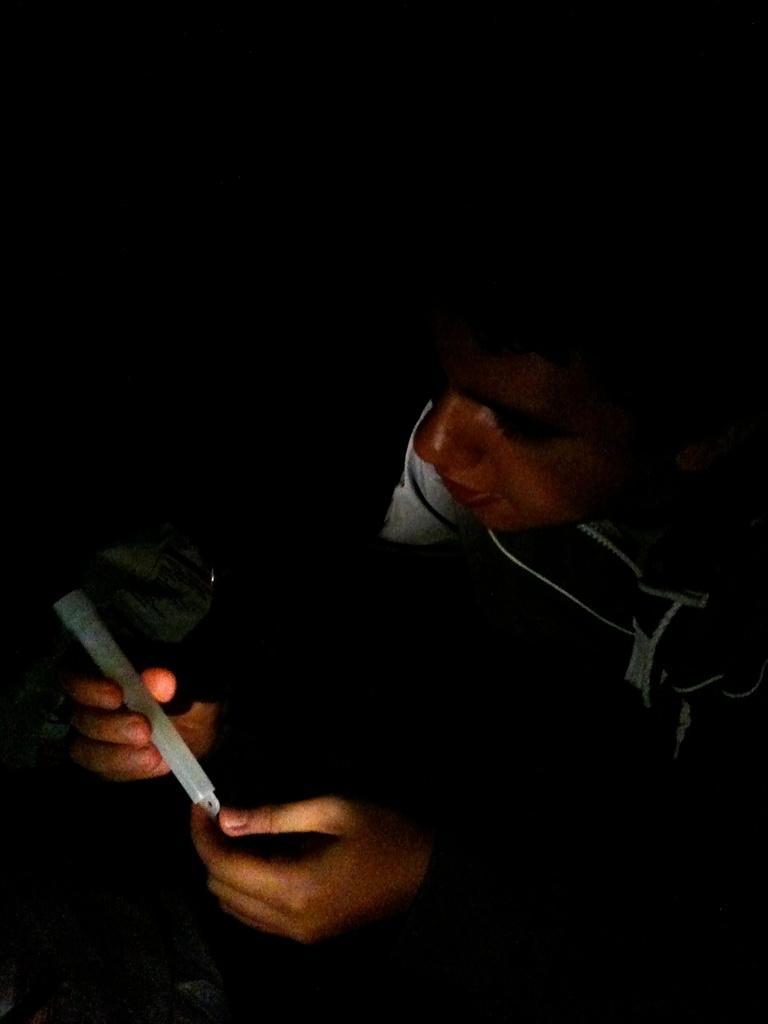Describe this image in one or two sentences. In this image there is a man who is looking at the candle which is in his hand. 